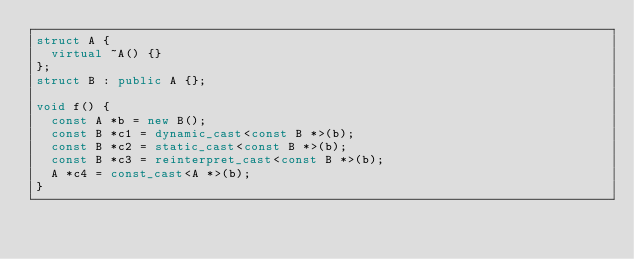<code> <loc_0><loc_0><loc_500><loc_500><_C++_>struct A {
  virtual ~A() {}
};
struct B : public A {};

void f() {
  const A *b = new B();
  const B *c1 = dynamic_cast<const B *>(b);
  const B *c2 = static_cast<const B *>(b);
  const B *c3 = reinterpret_cast<const B *>(b);
  A *c4 = const_cast<A *>(b);
}
</code> 